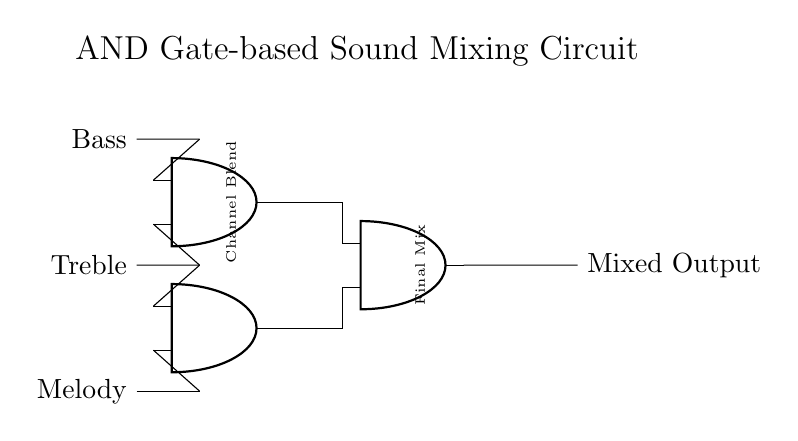What are the input channels in the circuit? The circuit includes three input channels labeled Bass, Treble, and Melody. These channels are depicted as node entries on the left side of the circuit diagram.
Answer: Bass, Treble, Melody How many AND gates are there in this circuit? The circuit contains three AND gates. This is determined by counting the AND gate symbols depicted in the diagram.
Answer: Three What is the output of the circuit called? The output of the circuit is labeled Mixed Output, which is positioned to the right of the last AND gate, indicating the result of the mixing process.
Answer: Mixed Output Which components are connected to the final AND gate? The final AND gate is connected to the outputs of the two preceding AND gates. In this case, it receives inputs from and1 and and2 as evident from the connections shown in the diagram.
Answer: Output from and1 and and2 What is the function of the AND gates in this circuit? The AND gates serve to combine the input channels by only allowing an output if all inputs are active, thus enabling a mixed output only when the specified channels are triggered. This logic is fundamental to sound mixing applications.
Answer: Combine input channels What type of mixing does this circuit represent? The circuit represents a channel blend mixing process. This is specified by the labeling of the first AND gate, indicating the goal of blending various sound channels together before producing a final output.
Answer: Channel Blend How many channels can this circuit mix simultaneously? The circuit can mix three channels simultaneously as denoted by the three input channels (Bass, Treble, Melody) connected to the AND gates for processing.
Answer: Three 